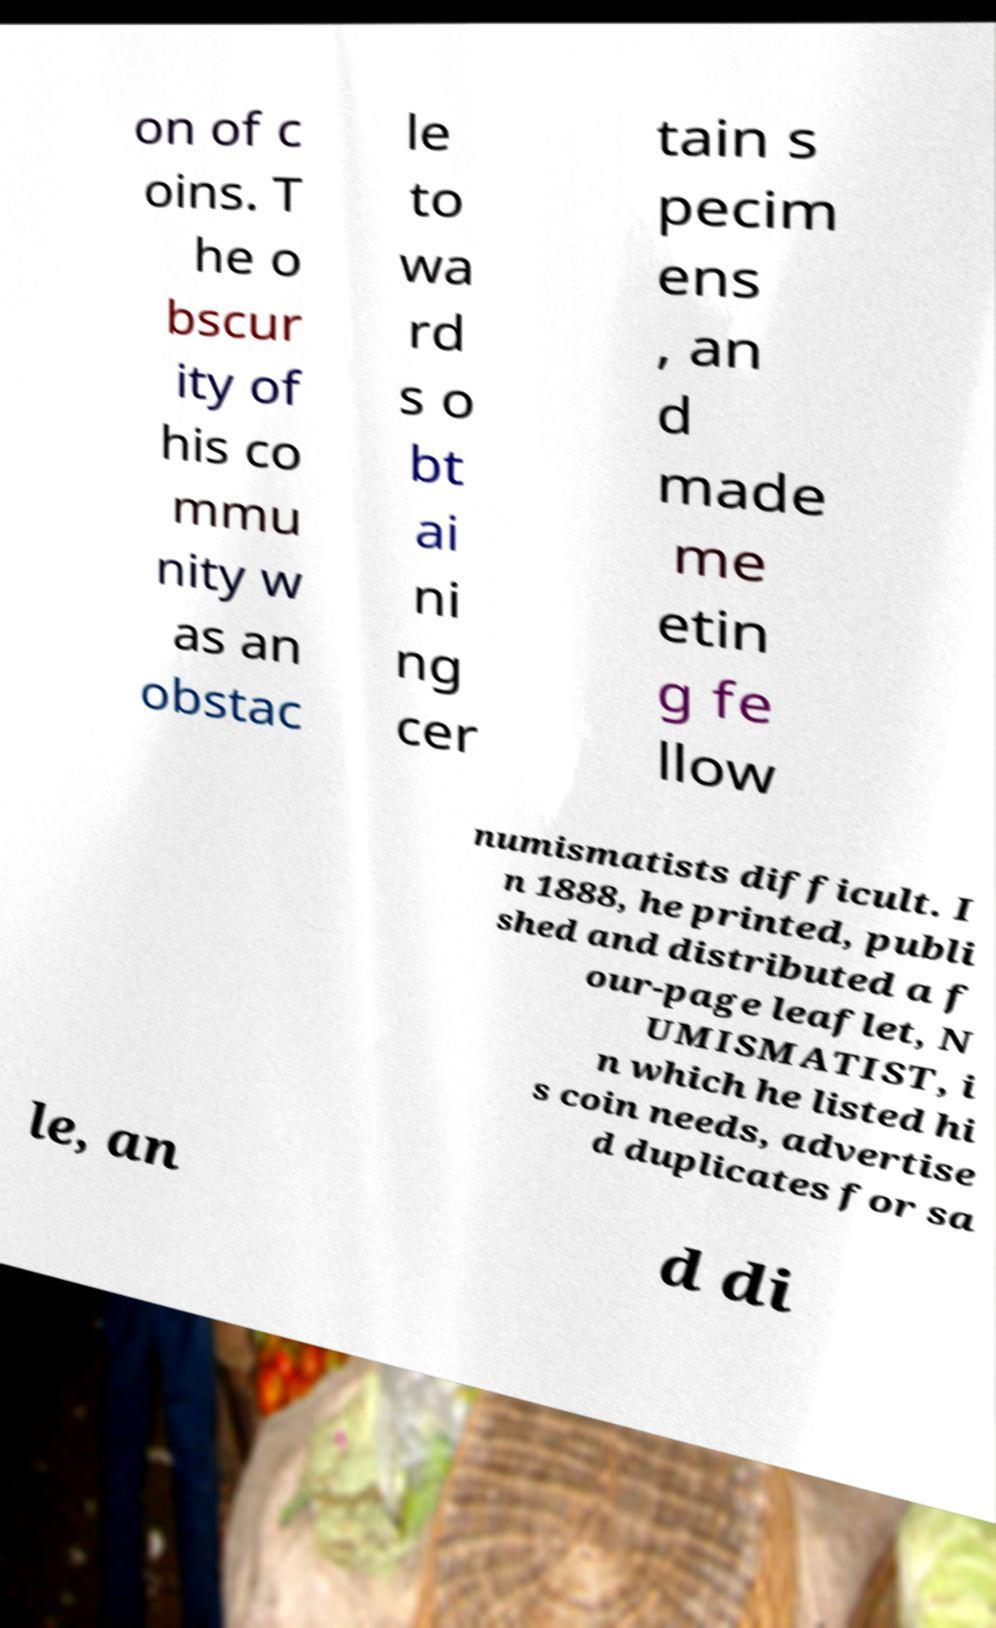Can you read and provide the text displayed in the image?This photo seems to have some interesting text. Can you extract and type it out for me? on of c oins. T he o bscur ity of his co mmu nity w as an obstac le to wa rd s o bt ai ni ng cer tain s pecim ens , an d made me etin g fe llow numismatists difficult. I n 1888, he printed, publi shed and distributed a f our-page leaflet, N UMISMATIST, i n which he listed hi s coin needs, advertise d duplicates for sa le, an d di 